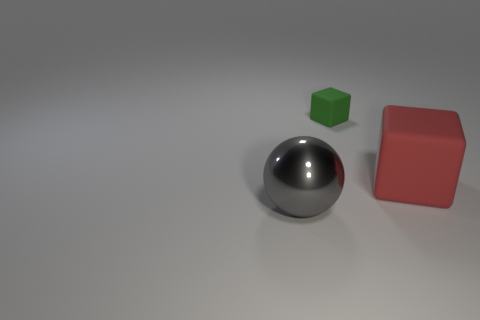Is there anything else that has the same shape as the metallic thing?
Offer a terse response. No. There is a object that is in front of the matte object in front of the small matte object; are there any red rubber blocks that are left of it?
Provide a short and direct response. No. The shiny ball is what color?
Provide a short and direct response. Gray. What is the color of the rubber cube that is the same size as the gray sphere?
Keep it short and to the point. Red. Do the large object to the right of the large shiny object and the gray thing have the same shape?
Your response must be concise. No. What color is the cube right of the block that is left of the large object behind the gray metallic sphere?
Keep it short and to the point. Red. Is there a big metallic sphere?
Make the answer very short. Yes. How many other things are the same size as the green rubber object?
Give a very brief answer. 0. There is a large shiny ball; does it have the same color as the rubber cube left of the large red block?
Offer a terse response. No. What number of objects are large cylinders or big objects?
Give a very brief answer. 2. 